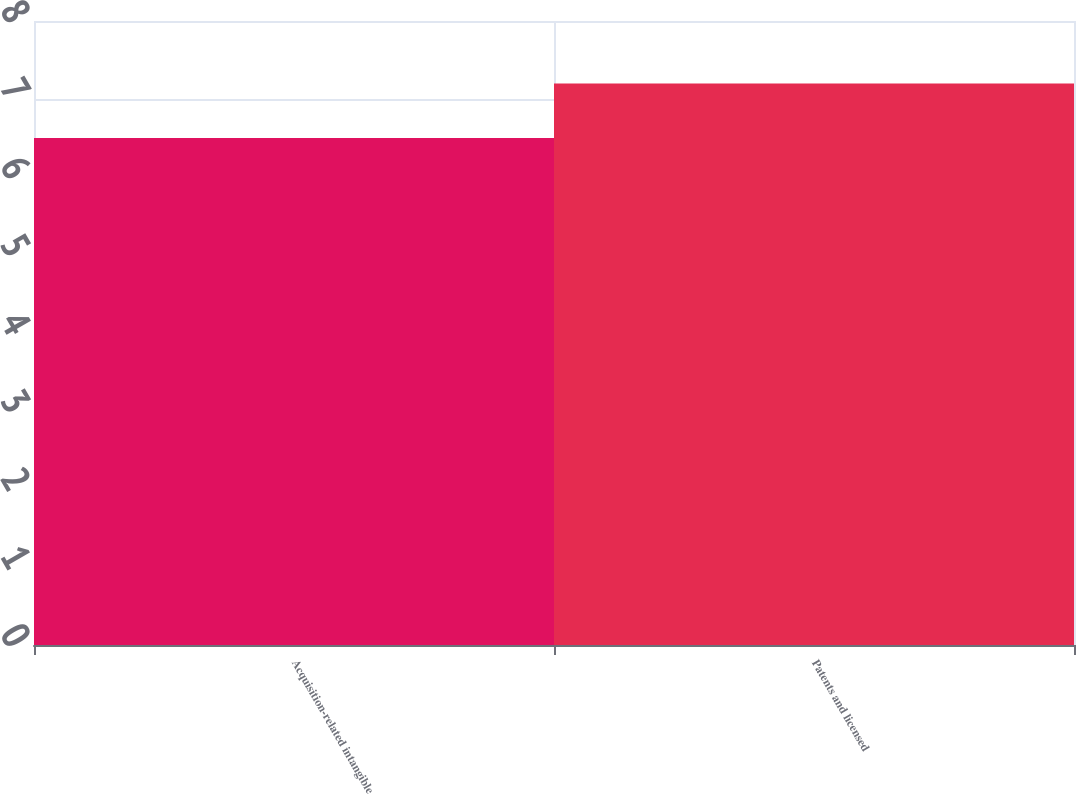Convert chart. <chart><loc_0><loc_0><loc_500><loc_500><bar_chart><fcel>Acquisition-related intangible<fcel>Patents and licensed<nl><fcel>6.5<fcel>7.2<nl></chart> 